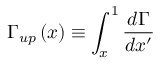Convert formula to latex. <formula><loc_0><loc_0><loc_500><loc_500>\Gamma _ { u p } \left ( x \right ) \equiv \int _ { x } ^ { 1 } \frac { d \Gamma } { d x ^ { \prime } }</formula> 